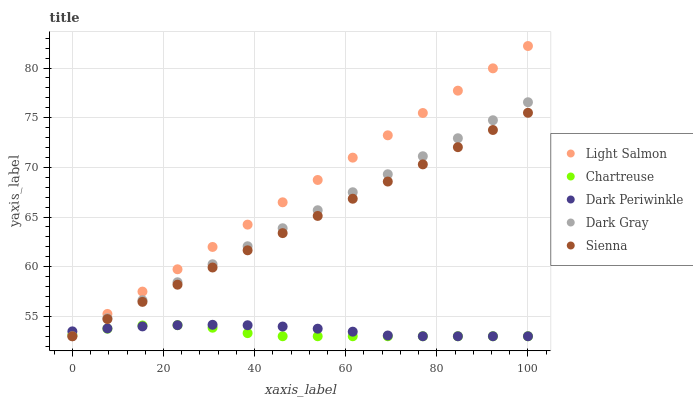Does Chartreuse have the minimum area under the curve?
Answer yes or no. Yes. Does Light Salmon have the maximum area under the curve?
Answer yes or no. Yes. Does Sienna have the minimum area under the curve?
Answer yes or no. No. Does Sienna have the maximum area under the curve?
Answer yes or no. No. Is Dark Gray the smoothest?
Answer yes or no. Yes. Is Chartreuse the roughest?
Answer yes or no. Yes. Is Sienna the smoothest?
Answer yes or no. No. Is Sienna the roughest?
Answer yes or no. No. Does Dark Gray have the lowest value?
Answer yes or no. Yes. Does Light Salmon have the highest value?
Answer yes or no. Yes. Does Sienna have the highest value?
Answer yes or no. No. Does Sienna intersect Dark Gray?
Answer yes or no. Yes. Is Sienna less than Dark Gray?
Answer yes or no. No. Is Sienna greater than Dark Gray?
Answer yes or no. No. 